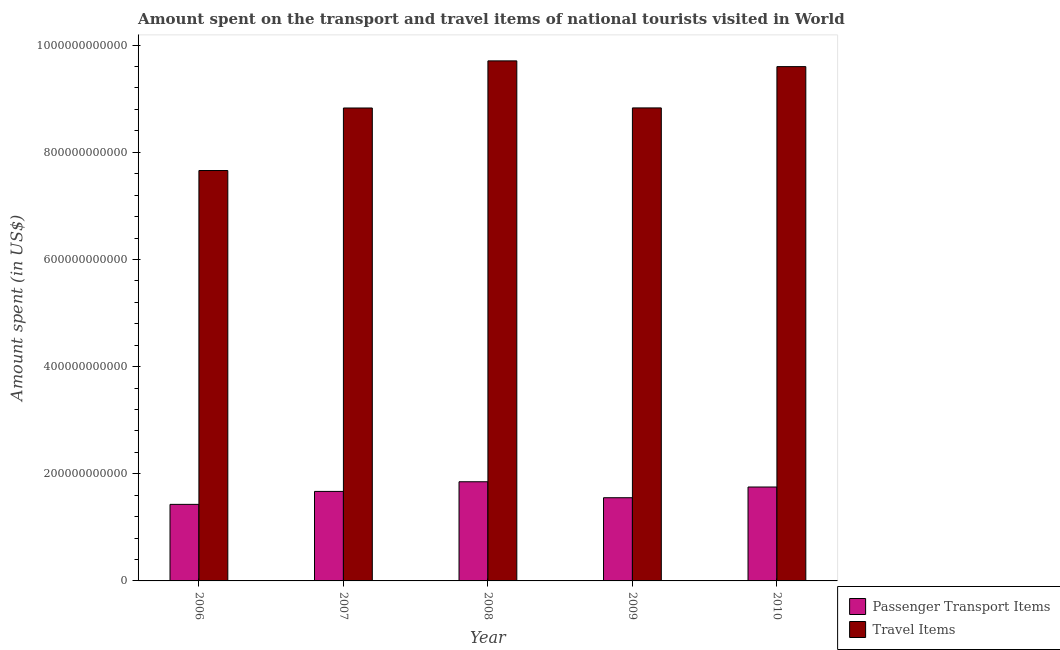How many different coloured bars are there?
Give a very brief answer. 2. Are the number of bars on each tick of the X-axis equal?
Ensure brevity in your answer.  Yes. How many bars are there on the 4th tick from the left?
Provide a short and direct response. 2. What is the label of the 4th group of bars from the left?
Your response must be concise. 2009. In how many cases, is the number of bars for a given year not equal to the number of legend labels?
Give a very brief answer. 0. What is the amount spent in travel items in 2006?
Your answer should be compact. 7.66e+11. Across all years, what is the maximum amount spent in travel items?
Your response must be concise. 9.71e+11. Across all years, what is the minimum amount spent on passenger transport items?
Provide a succinct answer. 1.43e+11. In which year was the amount spent in travel items maximum?
Provide a short and direct response. 2008. In which year was the amount spent on passenger transport items minimum?
Offer a very short reply. 2006. What is the total amount spent on passenger transport items in the graph?
Your answer should be compact. 8.26e+11. What is the difference between the amount spent on passenger transport items in 2006 and that in 2007?
Offer a terse response. -2.42e+1. What is the difference between the amount spent in travel items in 2010 and the amount spent on passenger transport items in 2007?
Your answer should be compact. 7.72e+1. What is the average amount spent in travel items per year?
Your answer should be very brief. 8.92e+11. What is the ratio of the amount spent on passenger transport items in 2006 to that in 2010?
Your answer should be very brief. 0.82. What is the difference between the highest and the second highest amount spent in travel items?
Provide a short and direct response. 1.07e+1. What is the difference between the highest and the lowest amount spent on passenger transport items?
Your response must be concise. 4.22e+1. In how many years, is the amount spent on passenger transport items greater than the average amount spent on passenger transport items taken over all years?
Give a very brief answer. 3. Is the sum of the amount spent in travel items in 2009 and 2010 greater than the maximum amount spent on passenger transport items across all years?
Provide a short and direct response. Yes. What does the 1st bar from the left in 2010 represents?
Offer a very short reply. Passenger Transport Items. What does the 1st bar from the right in 2006 represents?
Provide a short and direct response. Travel Items. Are all the bars in the graph horizontal?
Your answer should be compact. No. How many years are there in the graph?
Your response must be concise. 5. What is the difference between two consecutive major ticks on the Y-axis?
Offer a very short reply. 2.00e+11. Are the values on the major ticks of Y-axis written in scientific E-notation?
Offer a terse response. No. How many legend labels are there?
Provide a succinct answer. 2. What is the title of the graph?
Keep it short and to the point. Amount spent on the transport and travel items of national tourists visited in World. Does "Travel Items" appear as one of the legend labels in the graph?
Give a very brief answer. Yes. What is the label or title of the X-axis?
Offer a very short reply. Year. What is the label or title of the Y-axis?
Your answer should be very brief. Amount spent (in US$). What is the Amount spent (in US$) of Passenger Transport Items in 2006?
Your response must be concise. 1.43e+11. What is the Amount spent (in US$) in Travel Items in 2006?
Your response must be concise. 7.66e+11. What is the Amount spent (in US$) in Passenger Transport Items in 2007?
Offer a terse response. 1.67e+11. What is the Amount spent (in US$) of Travel Items in 2007?
Make the answer very short. 8.83e+11. What is the Amount spent (in US$) in Passenger Transport Items in 2008?
Keep it short and to the point. 1.85e+11. What is the Amount spent (in US$) in Travel Items in 2008?
Your answer should be compact. 9.71e+11. What is the Amount spent (in US$) in Passenger Transport Items in 2009?
Offer a terse response. 1.55e+11. What is the Amount spent (in US$) of Travel Items in 2009?
Ensure brevity in your answer.  8.83e+11. What is the Amount spent (in US$) in Passenger Transport Items in 2010?
Provide a short and direct response. 1.75e+11. What is the Amount spent (in US$) of Travel Items in 2010?
Keep it short and to the point. 9.60e+11. Across all years, what is the maximum Amount spent (in US$) in Passenger Transport Items?
Your answer should be compact. 1.85e+11. Across all years, what is the maximum Amount spent (in US$) in Travel Items?
Provide a short and direct response. 9.71e+11. Across all years, what is the minimum Amount spent (in US$) in Passenger Transport Items?
Keep it short and to the point. 1.43e+11. Across all years, what is the minimum Amount spent (in US$) in Travel Items?
Offer a very short reply. 7.66e+11. What is the total Amount spent (in US$) of Passenger Transport Items in the graph?
Your answer should be compact. 8.26e+11. What is the total Amount spent (in US$) of Travel Items in the graph?
Offer a terse response. 4.46e+12. What is the difference between the Amount spent (in US$) in Passenger Transport Items in 2006 and that in 2007?
Make the answer very short. -2.42e+1. What is the difference between the Amount spent (in US$) in Travel Items in 2006 and that in 2007?
Offer a terse response. -1.17e+11. What is the difference between the Amount spent (in US$) of Passenger Transport Items in 2006 and that in 2008?
Provide a succinct answer. -4.22e+1. What is the difference between the Amount spent (in US$) of Travel Items in 2006 and that in 2008?
Keep it short and to the point. -2.05e+11. What is the difference between the Amount spent (in US$) in Passenger Transport Items in 2006 and that in 2009?
Make the answer very short. -1.24e+1. What is the difference between the Amount spent (in US$) in Travel Items in 2006 and that in 2009?
Provide a succinct answer. -1.17e+11. What is the difference between the Amount spent (in US$) in Passenger Transport Items in 2006 and that in 2010?
Ensure brevity in your answer.  -3.24e+1. What is the difference between the Amount spent (in US$) in Travel Items in 2006 and that in 2010?
Your answer should be compact. -1.94e+11. What is the difference between the Amount spent (in US$) in Passenger Transport Items in 2007 and that in 2008?
Offer a terse response. -1.80e+1. What is the difference between the Amount spent (in US$) of Travel Items in 2007 and that in 2008?
Ensure brevity in your answer.  -8.79e+1. What is the difference between the Amount spent (in US$) in Passenger Transport Items in 2007 and that in 2009?
Offer a very short reply. 1.18e+1. What is the difference between the Amount spent (in US$) of Travel Items in 2007 and that in 2009?
Provide a short and direct response. -1.73e+08. What is the difference between the Amount spent (in US$) in Passenger Transport Items in 2007 and that in 2010?
Your answer should be very brief. -8.22e+09. What is the difference between the Amount spent (in US$) in Travel Items in 2007 and that in 2010?
Ensure brevity in your answer.  -7.72e+1. What is the difference between the Amount spent (in US$) of Passenger Transport Items in 2008 and that in 2009?
Keep it short and to the point. 2.98e+1. What is the difference between the Amount spent (in US$) of Travel Items in 2008 and that in 2009?
Ensure brevity in your answer.  8.78e+1. What is the difference between the Amount spent (in US$) in Passenger Transport Items in 2008 and that in 2010?
Give a very brief answer. 9.80e+09. What is the difference between the Amount spent (in US$) in Travel Items in 2008 and that in 2010?
Make the answer very short. 1.07e+1. What is the difference between the Amount spent (in US$) in Passenger Transport Items in 2009 and that in 2010?
Give a very brief answer. -2.00e+1. What is the difference between the Amount spent (in US$) of Travel Items in 2009 and that in 2010?
Offer a terse response. -7.70e+1. What is the difference between the Amount spent (in US$) in Passenger Transport Items in 2006 and the Amount spent (in US$) in Travel Items in 2007?
Offer a very short reply. -7.40e+11. What is the difference between the Amount spent (in US$) in Passenger Transport Items in 2006 and the Amount spent (in US$) in Travel Items in 2008?
Your answer should be very brief. -8.28e+11. What is the difference between the Amount spent (in US$) in Passenger Transport Items in 2006 and the Amount spent (in US$) in Travel Items in 2009?
Offer a very short reply. -7.40e+11. What is the difference between the Amount spent (in US$) in Passenger Transport Items in 2006 and the Amount spent (in US$) in Travel Items in 2010?
Offer a terse response. -8.17e+11. What is the difference between the Amount spent (in US$) in Passenger Transport Items in 2007 and the Amount spent (in US$) in Travel Items in 2008?
Your answer should be very brief. -8.04e+11. What is the difference between the Amount spent (in US$) of Passenger Transport Items in 2007 and the Amount spent (in US$) of Travel Items in 2009?
Your answer should be compact. -7.16e+11. What is the difference between the Amount spent (in US$) in Passenger Transport Items in 2007 and the Amount spent (in US$) in Travel Items in 2010?
Provide a short and direct response. -7.93e+11. What is the difference between the Amount spent (in US$) in Passenger Transport Items in 2008 and the Amount spent (in US$) in Travel Items in 2009?
Offer a very short reply. -6.98e+11. What is the difference between the Amount spent (in US$) of Passenger Transport Items in 2008 and the Amount spent (in US$) of Travel Items in 2010?
Offer a terse response. -7.75e+11. What is the difference between the Amount spent (in US$) of Passenger Transport Items in 2009 and the Amount spent (in US$) of Travel Items in 2010?
Make the answer very short. -8.05e+11. What is the average Amount spent (in US$) in Passenger Transport Items per year?
Your response must be concise. 1.65e+11. What is the average Amount spent (in US$) of Travel Items per year?
Provide a succinct answer. 8.92e+11. In the year 2006, what is the difference between the Amount spent (in US$) in Passenger Transport Items and Amount spent (in US$) in Travel Items?
Make the answer very short. -6.23e+11. In the year 2007, what is the difference between the Amount spent (in US$) of Passenger Transport Items and Amount spent (in US$) of Travel Items?
Ensure brevity in your answer.  -7.16e+11. In the year 2008, what is the difference between the Amount spent (in US$) in Passenger Transport Items and Amount spent (in US$) in Travel Items?
Make the answer very short. -7.86e+11. In the year 2009, what is the difference between the Amount spent (in US$) of Passenger Transport Items and Amount spent (in US$) of Travel Items?
Offer a very short reply. -7.28e+11. In the year 2010, what is the difference between the Amount spent (in US$) of Passenger Transport Items and Amount spent (in US$) of Travel Items?
Ensure brevity in your answer.  -7.85e+11. What is the ratio of the Amount spent (in US$) of Passenger Transport Items in 2006 to that in 2007?
Offer a terse response. 0.86. What is the ratio of the Amount spent (in US$) in Travel Items in 2006 to that in 2007?
Provide a short and direct response. 0.87. What is the ratio of the Amount spent (in US$) in Passenger Transport Items in 2006 to that in 2008?
Offer a terse response. 0.77. What is the ratio of the Amount spent (in US$) in Travel Items in 2006 to that in 2008?
Give a very brief answer. 0.79. What is the ratio of the Amount spent (in US$) of Passenger Transport Items in 2006 to that in 2009?
Ensure brevity in your answer.  0.92. What is the ratio of the Amount spent (in US$) of Travel Items in 2006 to that in 2009?
Your response must be concise. 0.87. What is the ratio of the Amount spent (in US$) of Passenger Transport Items in 2006 to that in 2010?
Offer a terse response. 0.82. What is the ratio of the Amount spent (in US$) in Travel Items in 2006 to that in 2010?
Make the answer very short. 0.8. What is the ratio of the Amount spent (in US$) in Passenger Transport Items in 2007 to that in 2008?
Offer a very short reply. 0.9. What is the ratio of the Amount spent (in US$) in Travel Items in 2007 to that in 2008?
Your response must be concise. 0.91. What is the ratio of the Amount spent (in US$) in Passenger Transport Items in 2007 to that in 2009?
Offer a terse response. 1.08. What is the ratio of the Amount spent (in US$) in Passenger Transport Items in 2007 to that in 2010?
Make the answer very short. 0.95. What is the ratio of the Amount spent (in US$) of Travel Items in 2007 to that in 2010?
Ensure brevity in your answer.  0.92. What is the ratio of the Amount spent (in US$) of Passenger Transport Items in 2008 to that in 2009?
Your answer should be very brief. 1.19. What is the ratio of the Amount spent (in US$) in Travel Items in 2008 to that in 2009?
Your response must be concise. 1.1. What is the ratio of the Amount spent (in US$) in Passenger Transport Items in 2008 to that in 2010?
Offer a very short reply. 1.06. What is the ratio of the Amount spent (in US$) in Travel Items in 2008 to that in 2010?
Keep it short and to the point. 1.01. What is the ratio of the Amount spent (in US$) of Passenger Transport Items in 2009 to that in 2010?
Make the answer very short. 0.89. What is the ratio of the Amount spent (in US$) in Travel Items in 2009 to that in 2010?
Give a very brief answer. 0.92. What is the difference between the highest and the second highest Amount spent (in US$) of Passenger Transport Items?
Offer a terse response. 9.80e+09. What is the difference between the highest and the second highest Amount spent (in US$) of Travel Items?
Your response must be concise. 1.07e+1. What is the difference between the highest and the lowest Amount spent (in US$) in Passenger Transport Items?
Your response must be concise. 4.22e+1. What is the difference between the highest and the lowest Amount spent (in US$) in Travel Items?
Provide a short and direct response. 2.05e+11. 